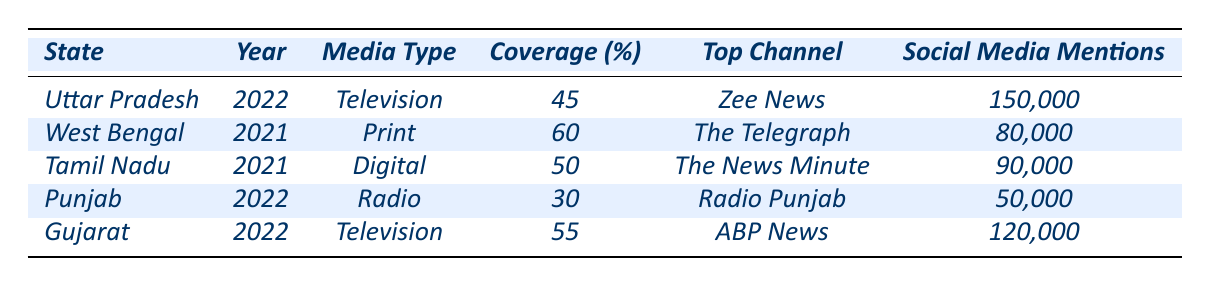What state had the highest media coverage percentage in the table? Looking at the coverage percentages, West Bengal has the highest at 60%.
Answer: West Bengal Which media type was utilized for the 2021 elections in Tamil Nadu? The media type for the 2021 elections in Tamil Nadu is Digital.
Answer: Digital How many social media mentions did Arvind Kejriwal's campaign receive during the Punjab elections? Arvind Kejriwal's campaign in Punjab received 50,000 social media mentions.
Answer: 50,000 What is the average coverage percentage of the elections listed in the table? The coverage percentages are 45, 60, 50, 30, and 55. Adding them gives 240, and dividing by 5 gives an average of 48%.
Answer: 48% Did the major parties in Uttar Pradesh include the Indian National Congress? The major parties listed for Uttar Pradesh do not include the Indian National Congress.
Answer: No What was the notable event associated with the highest social media mentions in the table? The notable event that received the highest social media mentions, with 150,000, was Yogi Adityanath's Ghar Wapsi Programme in Uttar Pradesh.
Answer: Yogi Adityanath's Ghar Wapsi Programme Which state had the lowest coverage percentage and what was it? Punjab had the lowest coverage percentage at 30%.
Answer: 30% Which media type received the most social media mentions in 2022? In 2022, the media types were Television for Uttar Pradesh and Gujarat, with Gujarat receiving 120,000 social media mentions.
Answer: Television Which top channel is associated with the highest coverage percentage? The top channel associated with the highest coverage percentage (60%) is The Telegraph from West Bengal.
Answer: The Telegraph How many major parties were mentioned for elections in Tamil Nadu? Two major parties were mentioned for the elections in Tamil Nadu: Dravida Munnetra Kazhagam and All India Anna Dravida Munnetra Kazhagam.
Answer: Two What is the difference in social media mentions between the elections in Gujarat and Punjab? Gujarat received 120,000 mentions and Punjab received 50,000. The difference is 120,000 - 50,000 = 70,000.
Answer: 70,000 